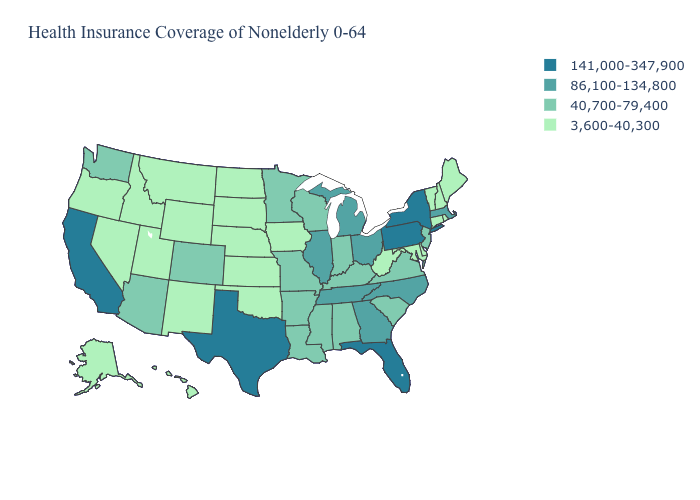Is the legend a continuous bar?
Answer briefly. No. Which states have the highest value in the USA?
Be succinct. California, Florida, New York, Pennsylvania, Texas. Is the legend a continuous bar?
Give a very brief answer. No. Does Tennessee have the highest value in the USA?
Concise answer only. No. What is the value of Utah?
Keep it brief. 3,600-40,300. What is the value of North Carolina?
Keep it brief. 86,100-134,800. Which states have the highest value in the USA?
Be succinct. California, Florida, New York, Pennsylvania, Texas. What is the value of Washington?
Write a very short answer. 40,700-79,400. What is the value of Pennsylvania?
Be succinct. 141,000-347,900. What is the value of Indiana?
Concise answer only. 40,700-79,400. What is the value of Michigan?
Give a very brief answer. 86,100-134,800. What is the value of Colorado?
Quick response, please. 40,700-79,400. How many symbols are there in the legend?
Be succinct. 4. What is the highest value in the West ?
Answer briefly. 141,000-347,900. Does Colorado have a higher value than Michigan?
Short answer required. No. 